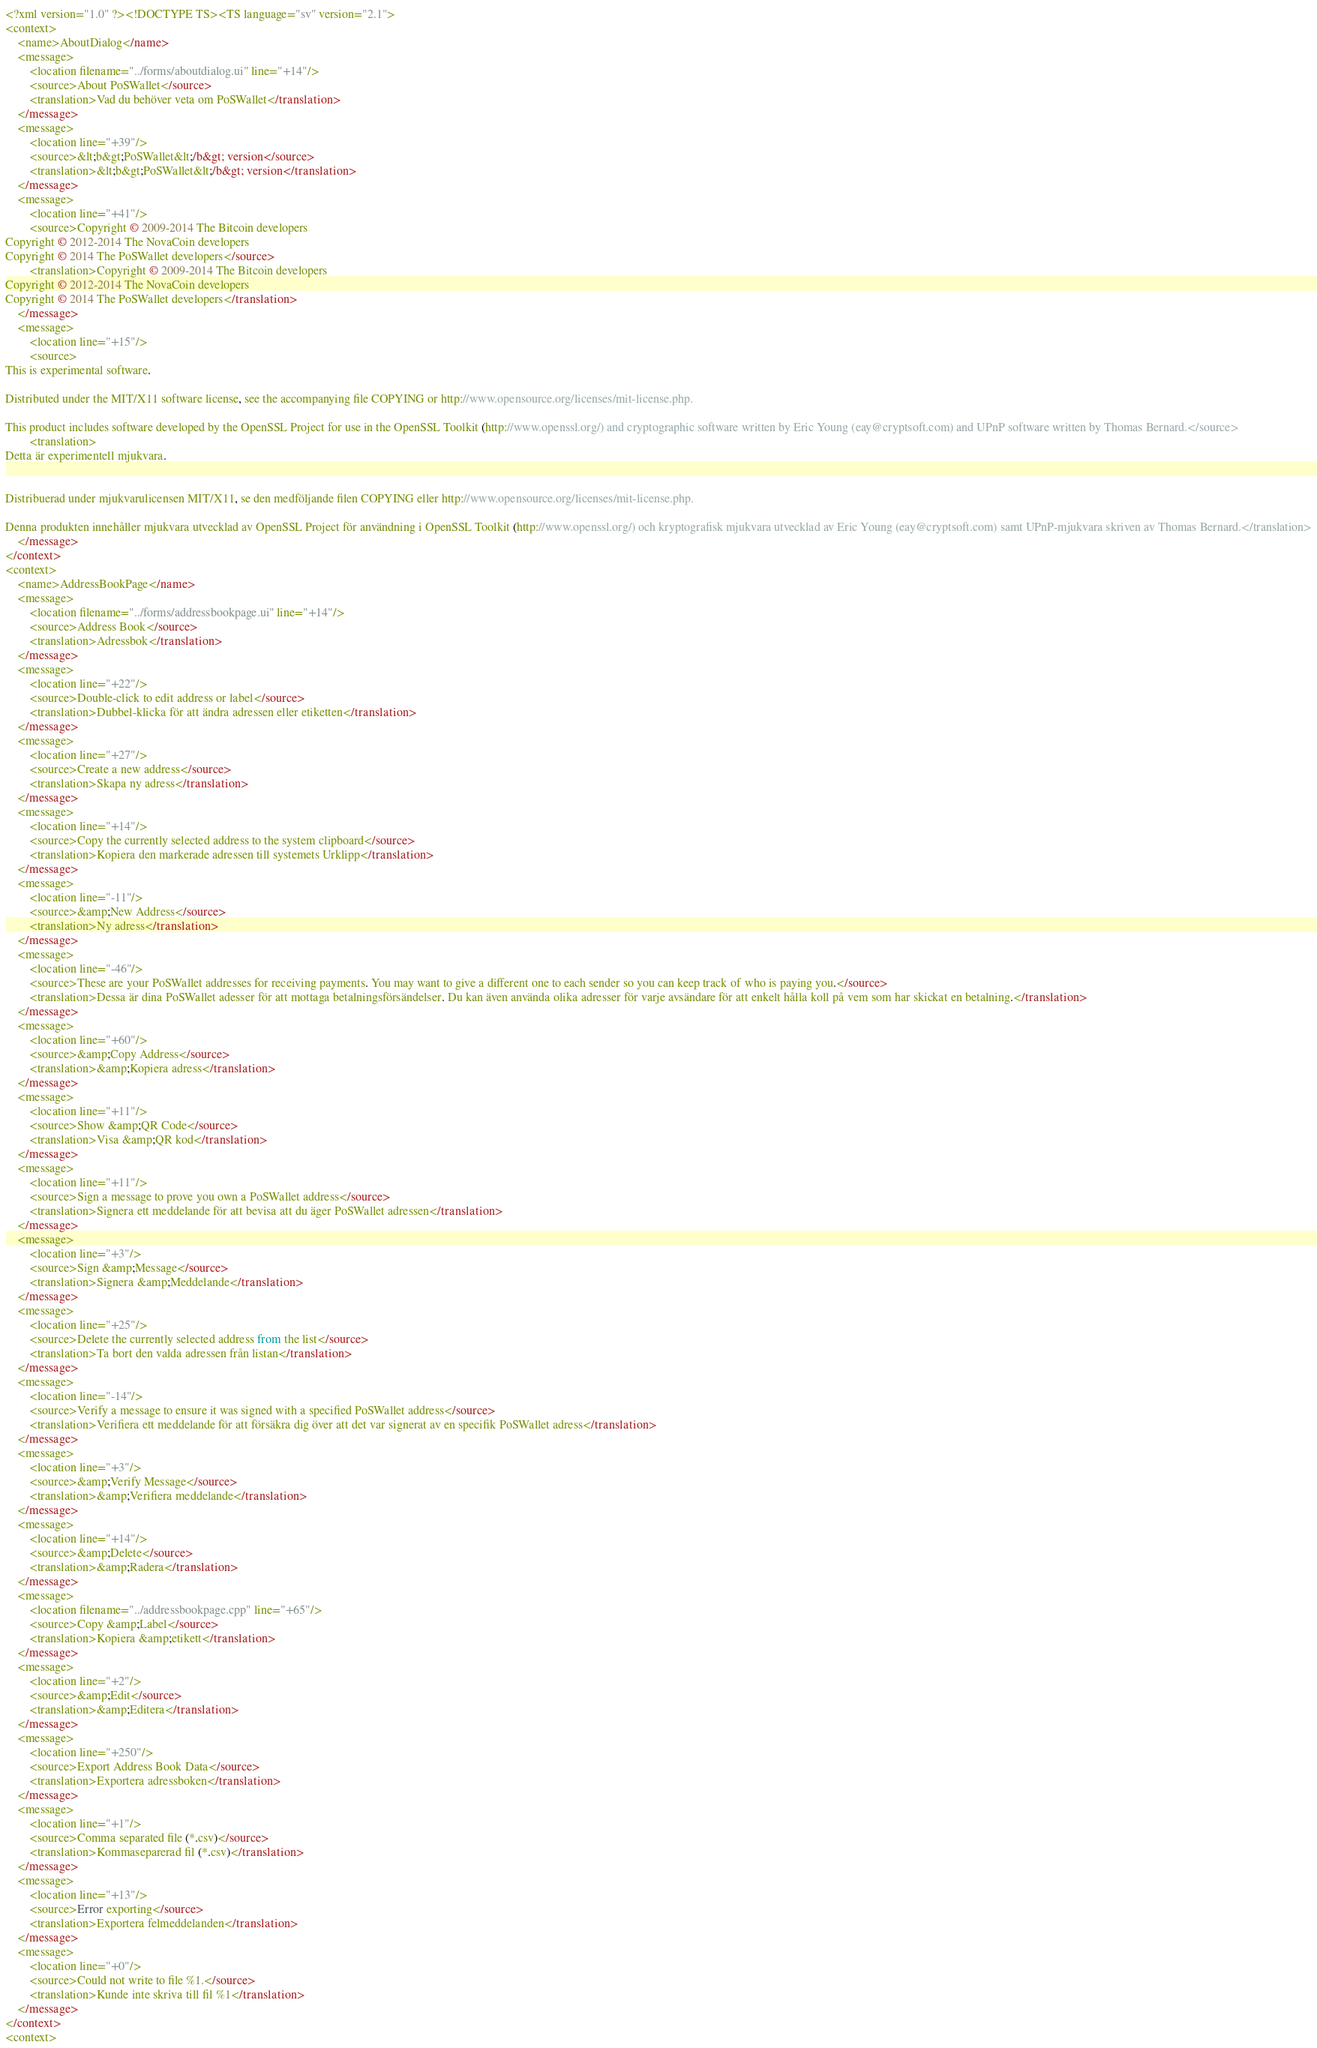Convert code to text. <code><loc_0><loc_0><loc_500><loc_500><_TypeScript_><?xml version="1.0" ?><!DOCTYPE TS><TS language="sv" version="2.1">
<context>
    <name>AboutDialog</name>
    <message>
        <location filename="../forms/aboutdialog.ui" line="+14"/>
        <source>About PoSWallet</source>
        <translation>Vad du behöver veta om PoSWallet</translation>
    </message>
    <message>
        <location line="+39"/>
        <source>&lt;b&gt;PoSWallet&lt;/b&gt; version</source>
        <translation>&lt;b&gt;PoSWallet&lt;/b&gt; version</translation>
    </message>
    <message>
        <location line="+41"/>
        <source>Copyright © 2009-2014 The Bitcoin developers
Copyright © 2012-2014 The NovaCoin developers
Copyright © 2014 The PoSWallet developers</source>
        <translation>Copyright © 2009-2014 The Bitcoin developers
Copyright © 2012-2014 The NovaCoin developers
Copyright © 2014 The PoSWallet developers</translation>
    </message>
    <message>
        <location line="+15"/>
        <source>
This is experimental software.

Distributed under the MIT/X11 software license, see the accompanying file COPYING or http://www.opensource.org/licenses/mit-license.php.

This product includes software developed by the OpenSSL Project for use in the OpenSSL Toolkit (http://www.openssl.org/) and cryptographic software written by Eric Young (eay@cryptsoft.com) and UPnP software written by Thomas Bernard.</source>
        <translation>
Detta är experimentell mjukvara.


Distribuerad under mjukvarulicensen MIT/X11, se den medföljande filen COPYING eller http://www.opensource.org/licenses/mit-license.php.

Denna produkten innehåller mjukvara utvecklad av OpenSSL Project för användning i OpenSSL Toolkit (http://www.openssl.org/) och kryptografisk mjukvara utvecklad av Eric Young (eay@cryptsoft.com) samt UPnP-mjukvara skriven av Thomas Bernard.</translation>
    </message>
</context>
<context>
    <name>AddressBookPage</name>
    <message>
        <location filename="../forms/addressbookpage.ui" line="+14"/>
        <source>Address Book</source>
        <translation>Adressbok</translation>
    </message>
    <message>
        <location line="+22"/>
        <source>Double-click to edit address or label</source>
        <translation>Dubbel-klicka för att ändra adressen eller etiketten</translation>
    </message>
    <message>
        <location line="+27"/>
        <source>Create a new address</source>
        <translation>Skapa ny adress</translation>
    </message>
    <message>
        <location line="+14"/>
        <source>Copy the currently selected address to the system clipboard</source>
        <translation>Kopiera den markerade adressen till systemets Urklipp</translation>
    </message>
    <message>
        <location line="-11"/>
        <source>&amp;New Address</source>
        <translation>Ny adress</translation>
    </message>
    <message>
        <location line="-46"/>
        <source>These are your PoSWallet addresses for receiving payments. You may want to give a different one to each sender so you can keep track of who is paying you.</source>
        <translation>Dessa är dina PoSWallet adesser för att mottaga betalningsförsändelser. Du kan även använda olika adresser för varje avsändare för att enkelt hålla koll på vem som har skickat en betalning.</translation>
    </message>
    <message>
        <location line="+60"/>
        <source>&amp;Copy Address</source>
        <translation>&amp;Kopiera adress</translation>
    </message>
    <message>
        <location line="+11"/>
        <source>Show &amp;QR Code</source>
        <translation>Visa &amp;QR kod</translation>
    </message>
    <message>
        <location line="+11"/>
        <source>Sign a message to prove you own a PoSWallet address</source>
        <translation>Signera ett meddelande för att bevisa att du äger PoSWallet adressen</translation>
    </message>
    <message>
        <location line="+3"/>
        <source>Sign &amp;Message</source>
        <translation>Signera &amp;Meddelande</translation>
    </message>
    <message>
        <location line="+25"/>
        <source>Delete the currently selected address from the list</source>
        <translation>Ta bort den valda adressen från listan</translation>
    </message>
    <message>
        <location line="-14"/>
        <source>Verify a message to ensure it was signed with a specified PoSWallet address</source>
        <translation>Verifiera ett meddelande för att försäkra dig över att det var signerat av en specifik PoSWallet adress</translation>
    </message>
    <message>
        <location line="+3"/>
        <source>&amp;Verify Message</source>
        <translation>&amp;Verifiera meddelande</translation>
    </message>
    <message>
        <location line="+14"/>
        <source>&amp;Delete</source>
        <translation>&amp;Radera</translation>
    </message>
    <message>
        <location filename="../addressbookpage.cpp" line="+65"/>
        <source>Copy &amp;Label</source>
        <translation>Kopiera &amp;etikett</translation>
    </message>
    <message>
        <location line="+2"/>
        <source>&amp;Edit</source>
        <translation>&amp;Editera</translation>
    </message>
    <message>
        <location line="+250"/>
        <source>Export Address Book Data</source>
        <translation>Exportera adressboken</translation>
    </message>
    <message>
        <location line="+1"/>
        <source>Comma separated file (*.csv)</source>
        <translation>Kommaseparerad fil (*.csv)</translation>
    </message>
    <message>
        <location line="+13"/>
        <source>Error exporting</source>
        <translation>Exportera felmeddelanden</translation>
    </message>
    <message>
        <location line="+0"/>
        <source>Could not write to file %1.</source>
        <translation>Kunde inte skriva till fil %1</translation>
    </message>
</context>
<context></code> 